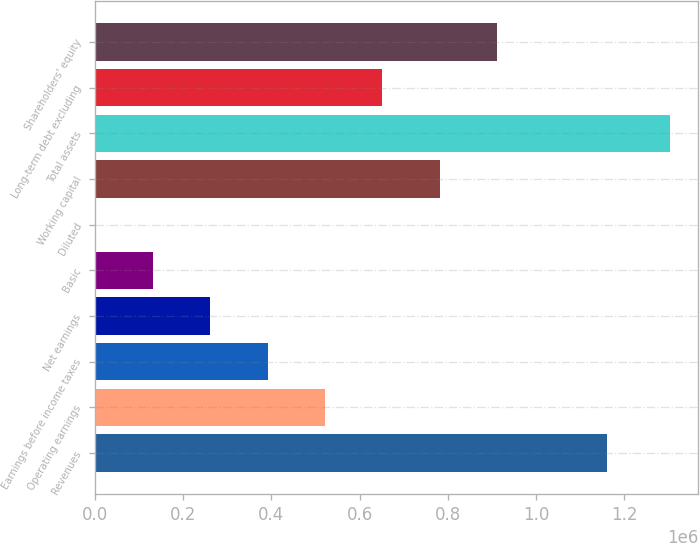Convert chart to OTSL. <chart><loc_0><loc_0><loc_500><loc_500><bar_chart><fcel>Revenues<fcel>Operating earnings<fcel>Earnings before income taxes<fcel>Net earnings<fcel>Basic<fcel>Diluted<fcel>Working capital<fcel>Total assets<fcel>Long-term debt excluding<fcel>Shareholders' equity<nl><fcel>1.16078e+06<fcel>521452<fcel>391089<fcel>260727<fcel>130364<fcel>1.1<fcel>782178<fcel>1.30363e+06<fcel>651815<fcel>912541<nl></chart> 